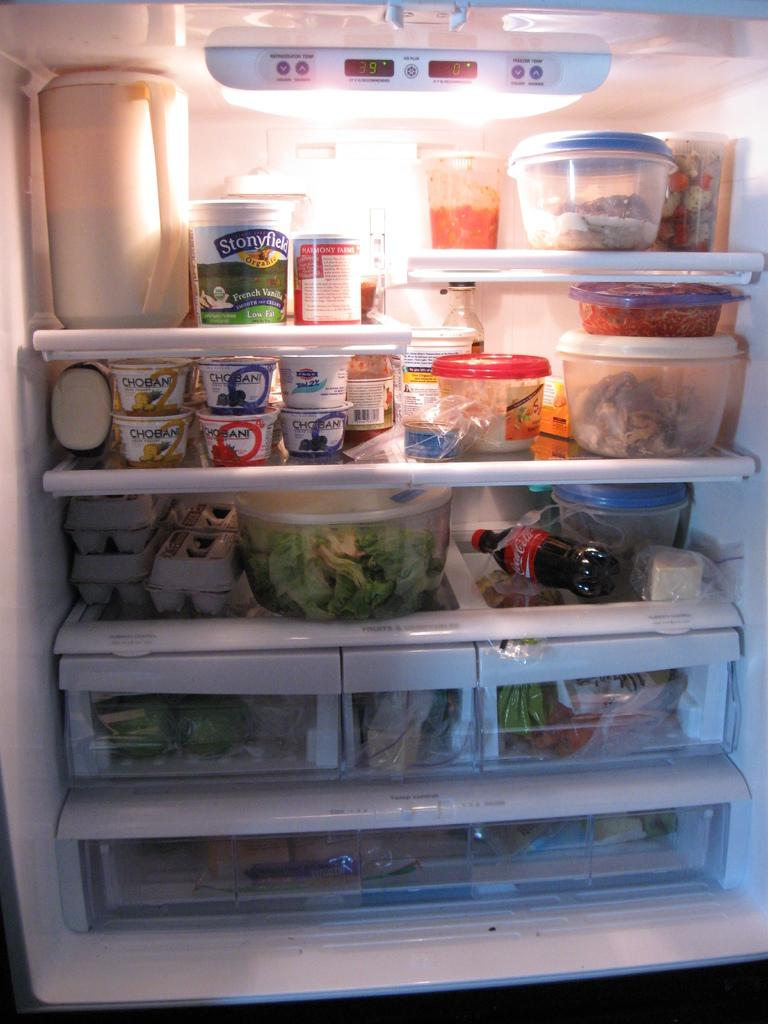<image>
Summarize the visual content of the image. The refrigerator is filled with healthy foods like greek yogurt, eggs and vegetables. 